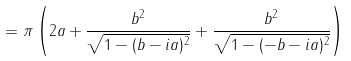<formula> <loc_0><loc_0><loc_500><loc_500>= \pi \left ( 2 a + \frac { b ^ { 2 } } { \sqrt { 1 - ( b - i a ) ^ { 2 } } } + \frac { b ^ { 2 } } { \sqrt { 1 - ( - b - i a ) ^ { 2 } } } \right )</formula> 